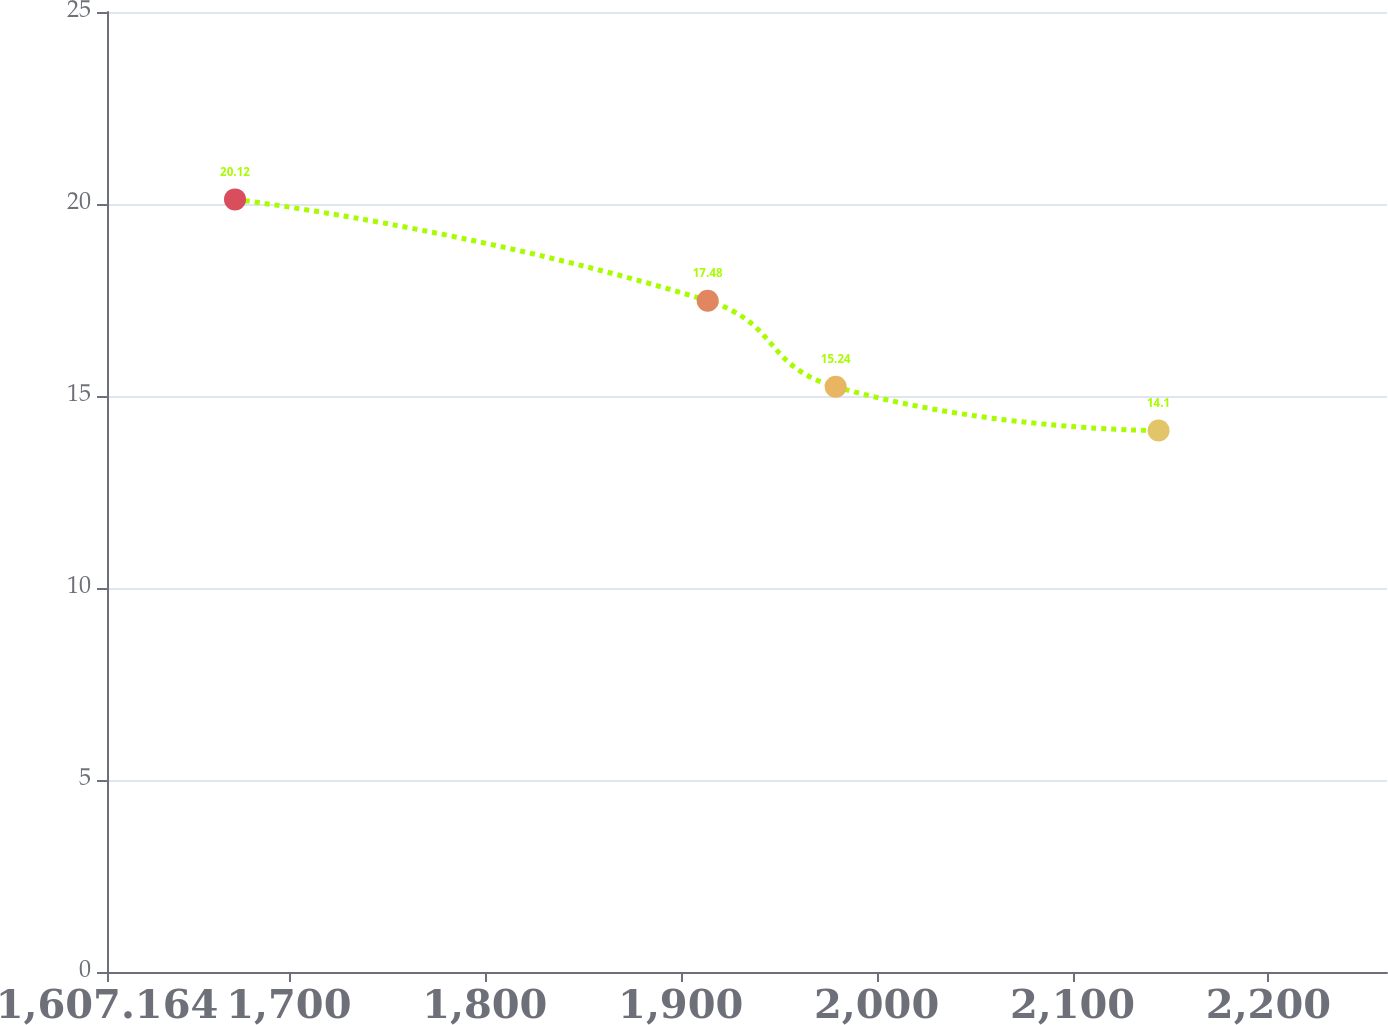Convert chart to OTSL. <chart><loc_0><loc_0><loc_500><loc_500><line_chart><ecel><fcel>Unnamed: 1<nl><fcel>1672.5<fcel>20.12<nl><fcel>1913.78<fcel>17.48<nl><fcel>1979.12<fcel>15.24<nl><fcel>2143.92<fcel>14.1<nl><fcel>2325.86<fcel>8.71<nl></chart> 